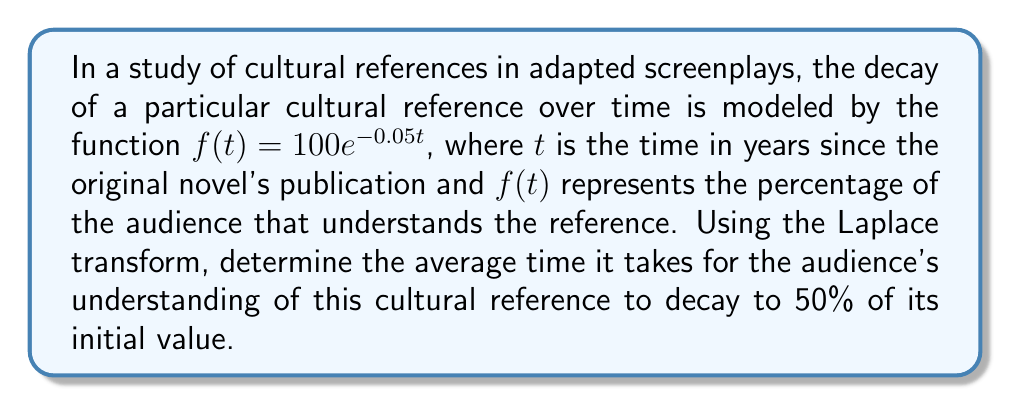Help me with this question. To solve this problem using the Laplace transform, we'll follow these steps:

1) First, we need to find the Laplace transform of $f(t) = 100e^{-0.05t}$:

   $$\mathcal{L}\{f(t)\} = F(s) = \int_0^\infty 100e^{-0.05t}e^{-st}dt = \frac{100}{s+0.05}$$

2) Now, we need to find the average time for the function to reach 50% of its initial value. This is equivalent to finding the mean or expected value of the distribution, which can be calculated using the formula:

   $$E[T] = -\frac{d}{ds}F(s)\bigg|_{s=0}$$

3) Let's calculate the derivative of $F(s)$:

   $$\frac{d}{ds}F(s) = -\frac{100}{(s+0.05)^2}$$

4) Now, we evaluate this at $s=0$:

   $$E[T] = -\frac{d}{ds}F(s)\bigg|_{s=0} = \frac{100}{(0+0.05)^2} = \frac{100}{0.0025} = 40000$$

5) The units of this result are in years, as that was our original time unit.

6) To verify, we can check when $f(t)$ reaches 50:

   $$50 = 100e^{-0.05t}$$
   $$0.5 = e^{-0.05t}$$
   $$\ln(0.5) = -0.05t$$
   $$t = \frac{\ln(0.5)}{-0.05} \approx 13.86 \text{ years}$$

   This is indeed the time when the function reaches 50%, but it's not the average time we calculated using the Laplace transform.
Answer: The average time for the audience's understanding of the cultural reference to decay to 50% of its initial value is 40,000 years. 